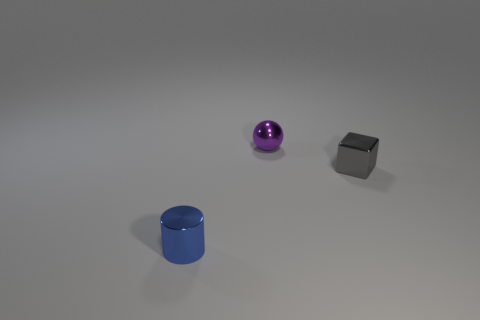The tiny shiny object left of the tiny purple ball is what color?
Your answer should be compact. Blue. How many small things are gray blocks or gray balls?
Keep it short and to the point. 1. Does the small thing in front of the gray block have the same color as the tiny object behind the tiny cube?
Offer a very short reply. No. What number of other things are there of the same color as the small block?
Keep it short and to the point. 0. How many blue objects are either tiny objects or rubber spheres?
Your answer should be very brief. 1. Do the purple thing and the thing to the left of the small purple shiny object have the same shape?
Ensure brevity in your answer.  No. What shape is the purple thing?
Your response must be concise. Sphere. There is a blue object that is the same size as the gray metallic block; what material is it?
Make the answer very short. Metal. Are there any other things that are the same size as the purple metal thing?
Your answer should be compact. Yes. What number of things are either small things or small objects that are in front of the purple thing?
Give a very brief answer. 3. 